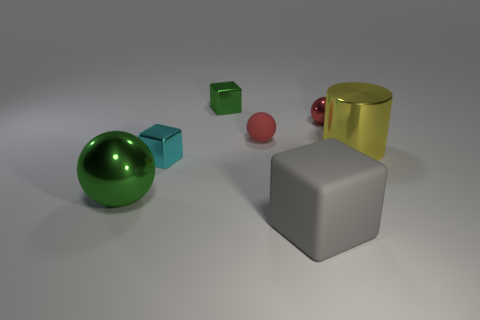Add 2 large gray cubes. How many objects exist? 9 Subtract all cubes. How many objects are left? 4 Subtract all purple balls. Subtract all large metallic objects. How many objects are left? 5 Add 5 big metal things. How many big metal things are left? 7 Add 1 large yellow objects. How many large yellow objects exist? 2 Subtract 0 blue cylinders. How many objects are left? 7 